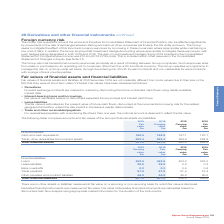According to Spirax Sarco Engineering Plc's financial document, Why are the fair values of financial assets and liabilities at 2019 not materially different from book values? due to their size or the fact that they were at short-term rates of interest. The document states: "019 are not materially different from book values due to their size or the fact that they were at short-term rates of interest. Fair values have been ..." Also, How are forward exchange contracts marked to market? by discounting the future contracted cash flows using readily available market data. The document states: "s Forward exchange contracts are marked to market by discounting the future contracted cash flows using readily available market data...." Also, What are the components under financial assets? The document shows two values: Cash and cash equivalents and Trade, other receivables and contract assets. From the document: "Cash and cash equivalents 168.5 168.5 187.1 187.1 Trade, other receivables and contract assets 263.4 263.4 264.9 264.9 Total financial assets 431.9 43..." Additionally, In which year was the carrying value for trade, other receivables and contract assets larger? According to the financial document, 2018. The relevant text states: "ith such hedges being designated in both 2019 and 2018. The gain on net investment hedges during 2019 included in the Consolidated Statement of Comprehens..." Also, can you calculate: What was the change in the carrying value in total financial assets from 2018 to 2019? Based on the calculation: 431.9-452.0, the result is -20.1 (in millions). This is based on the information: ".4 264.9 264.9 Total financial assets 431.9 431.9 452.0 452.0 ts 263.4 263.4 264.9 264.9 Total financial assets 431.9 431.9 452.0 452.0..." The key data points involved are: 431.9, 452.0. Also, can you calculate: What was the percentage change in the carrying value in total financial assets from 2018 to 2019? To answer this question, I need to perform calculations using the financial data. The calculation is: (431.9-452.0)/452.0, which equals -4.45 (percentage). This is based on the information: ".4 264.9 264.9 Total financial assets 431.9 431.9 452.0 452.0 ts 263.4 263.4 264.9 264.9 Total financial assets 431.9 431.9 452.0 452.0..." The key data points involved are: 431.9, 452.0. 